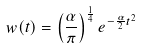Convert formula to latex. <formula><loc_0><loc_0><loc_500><loc_500>w ( t ) = \left ( \frac { \alpha } { \pi } \right ) ^ { \frac { 1 } { 4 } } e ^ { - \frac { \alpha } { 2 } t ^ { 2 } }</formula> 